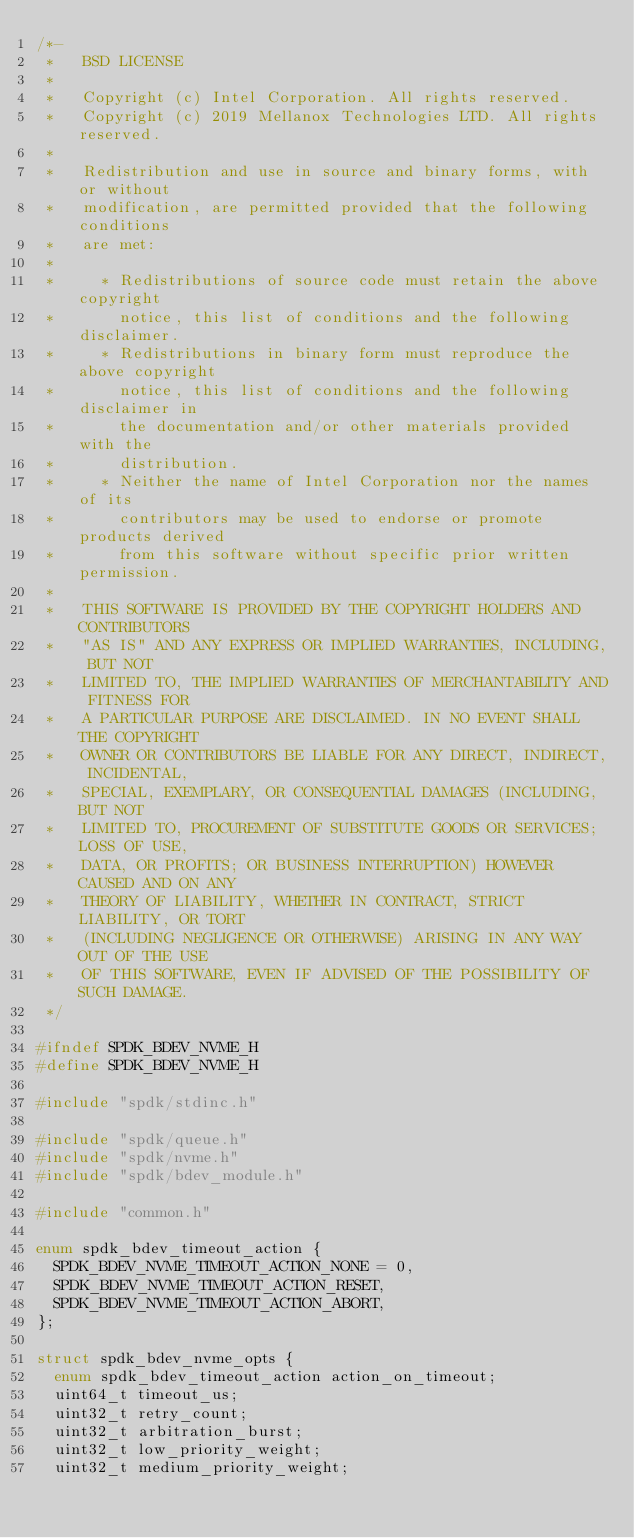Convert code to text. <code><loc_0><loc_0><loc_500><loc_500><_C_>/*-
 *   BSD LICENSE
 *
 *   Copyright (c) Intel Corporation. All rights reserved.
 *   Copyright (c) 2019 Mellanox Technologies LTD. All rights reserved.
 *
 *   Redistribution and use in source and binary forms, with or without
 *   modification, are permitted provided that the following conditions
 *   are met:
 *
 *     * Redistributions of source code must retain the above copyright
 *       notice, this list of conditions and the following disclaimer.
 *     * Redistributions in binary form must reproduce the above copyright
 *       notice, this list of conditions and the following disclaimer in
 *       the documentation and/or other materials provided with the
 *       distribution.
 *     * Neither the name of Intel Corporation nor the names of its
 *       contributors may be used to endorse or promote products derived
 *       from this software without specific prior written permission.
 *
 *   THIS SOFTWARE IS PROVIDED BY THE COPYRIGHT HOLDERS AND CONTRIBUTORS
 *   "AS IS" AND ANY EXPRESS OR IMPLIED WARRANTIES, INCLUDING, BUT NOT
 *   LIMITED TO, THE IMPLIED WARRANTIES OF MERCHANTABILITY AND FITNESS FOR
 *   A PARTICULAR PURPOSE ARE DISCLAIMED. IN NO EVENT SHALL THE COPYRIGHT
 *   OWNER OR CONTRIBUTORS BE LIABLE FOR ANY DIRECT, INDIRECT, INCIDENTAL,
 *   SPECIAL, EXEMPLARY, OR CONSEQUENTIAL DAMAGES (INCLUDING, BUT NOT
 *   LIMITED TO, PROCUREMENT OF SUBSTITUTE GOODS OR SERVICES; LOSS OF USE,
 *   DATA, OR PROFITS; OR BUSINESS INTERRUPTION) HOWEVER CAUSED AND ON ANY
 *   THEORY OF LIABILITY, WHETHER IN CONTRACT, STRICT LIABILITY, OR TORT
 *   (INCLUDING NEGLIGENCE OR OTHERWISE) ARISING IN ANY WAY OUT OF THE USE
 *   OF THIS SOFTWARE, EVEN IF ADVISED OF THE POSSIBILITY OF SUCH DAMAGE.
 */

#ifndef SPDK_BDEV_NVME_H
#define SPDK_BDEV_NVME_H

#include "spdk/stdinc.h"

#include "spdk/queue.h"
#include "spdk/nvme.h"
#include "spdk/bdev_module.h"

#include "common.h"

enum spdk_bdev_timeout_action {
	SPDK_BDEV_NVME_TIMEOUT_ACTION_NONE = 0,
	SPDK_BDEV_NVME_TIMEOUT_ACTION_RESET,
	SPDK_BDEV_NVME_TIMEOUT_ACTION_ABORT,
};

struct spdk_bdev_nvme_opts {
	enum spdk_bdev_timeout_action action_on_timeout;
	uint64_t timeout_us;
	uint32_t retry_count;
	uint32_t arbitration_burst;
	uint32_t low_priority_weight;
	uint32_t medium_priority_weight;</code> 